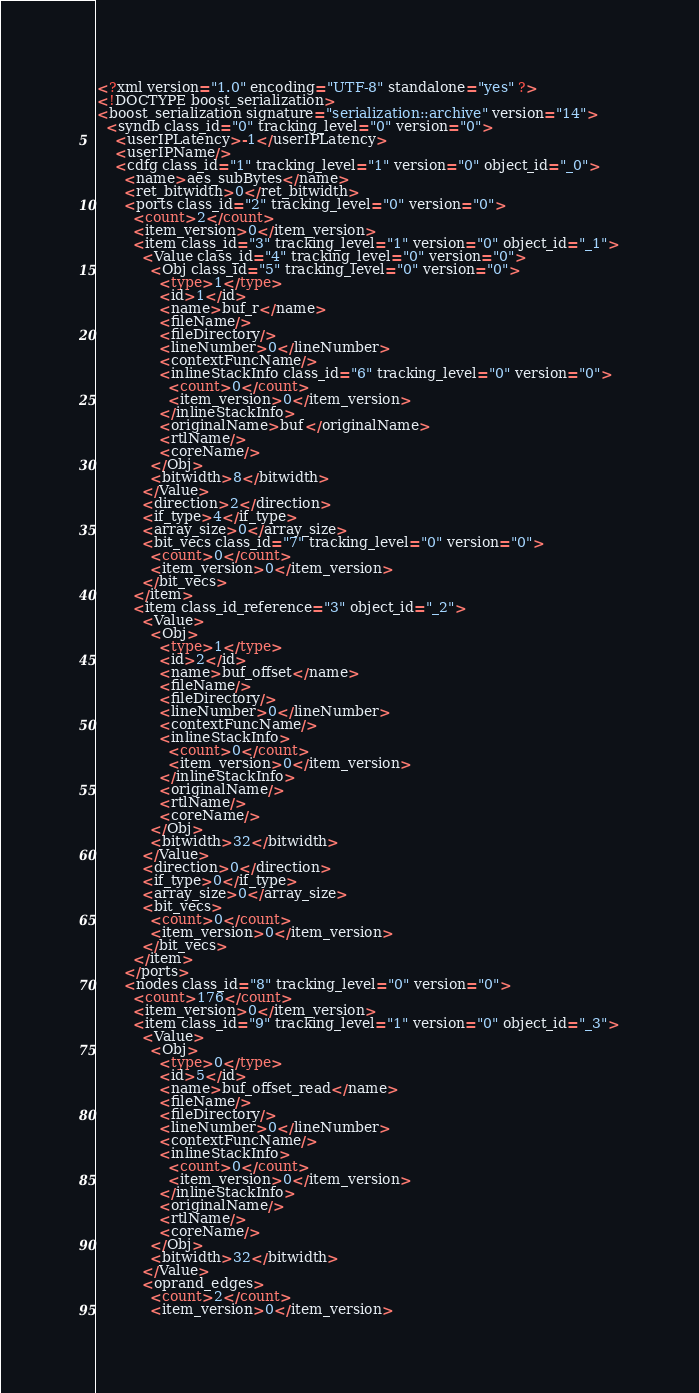<code> <loc_0><loc_0><loc_500><loc_500><_Ada_><?xml version="1.0" encoding="UTF-8" standalone="yes" ?>
<!DOCTYPE boost_serialization>
<boost_serialization signature="serialization::archive" version="14">
  <syndb class_id="0" tracking_level="0" version="0">
    <userIPLatency>-1</userIPLatency>
    <userIPName/>
    <cdfg class_id="1" tracking_level="1" version="0" object_id="_0">
      <name>aes_subBytes</name>
      <ret_bitwidth>0</ret_bitwidth>
      <ports class_id="2" tracking_level="0" version="0">
        <count>2</count>
        <item_version>0</item_version>
        <item class_id="3" tracking_level="1" version="0" object_id="_1">
          <Value class_id="4" tracking_level="0" version="0">
            <Obj class_id="5" tracking_level="0" version="0">
              <type>1</type>
              <id>1</id>
              <name>buf_r</name>
              <fileName/>
              <fileDirectory/>
              <lineNumber>0</lineNumber>
              <contextFuncName/>
              <inlineStackInfo class_id="6" tracking_level="0" version="0">
                <count>0</count>
                <item_version>0</item_version>
              </inlineStackInfo>
              <originalName>buf</originalName>
              <rtlName/>
              <coreName/>
            </Obj>
            <bitwidth>8</bitwidth>
          </Value>
          <direction>2</direction>
          <if_type>4</if_type>
          <array_size>0</array_size>
          <bit_vecs class_id="7" tracking_level="0" version="0">
            <count>0</count>
            <item_version>0</item_version>
          </bit_vecs>
        </item>
        <item class_id_reference="3" object_id="_2">
          <Value>
            <Obj>
              <type>1</type>
              <id>2</id>
              <name>buf_offset</name>
              <fileName/>
              <fileDirectory/>
              <lineNumber>0</lineNumber>
              <contextFuncName/>
              <inlineStackInfo>
                <count>0</count>
                <item_version>0</item_version>
              </inlineStackInfo>
              <originalName/>
              <rtlName/>
              <coreName/>
            </Obj>
            <bitwidth>32</bitwidth>
          </Value>
          <direction>0</direction>
          <if_type>0</if_type>
          <array_size>0</array_size>
          <bit_vecs>
            <count>0</count>
            <item_version>0</item_version>
          </bit_vecs>
        </item>
      </ports>
      <nodes class_id="8" tracking_level="0" version="0">
        <count>176</count>
        <item_version>0</item_version>
        <item class_id="9" tracking_level="1" version="0" object_id="_3">
          <Value>
            <Obj>
              <type>0</type>
              <id>5</id>
              <name>buf_offset_read</name>
              <fileName/>
              <fileDirectory/>
              <lineNumber>0</lineNumber>
              <contextFuncName/>
              <inlineStackInfo>
                <count>0</count>
                <item_version>0</item_version>
              </inlineStackInfo>
              <originalName/>
              <rtlName/>
              <coreName/>
            </Obj>
            <bitwidth>32</bitwidth>
          </Value>
          <oprand_edges>
            <count>2</count>
            <item_version>0</item_version></code> 